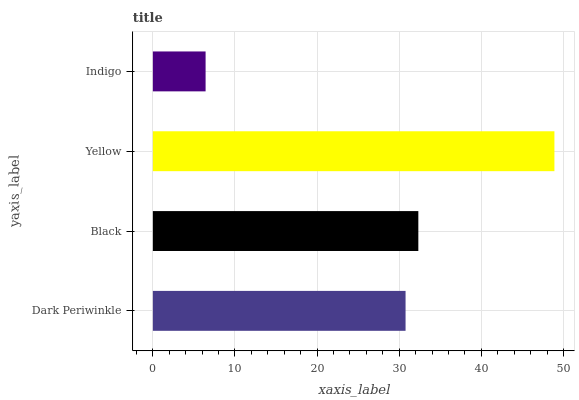Is Indigo the minimum?
Answer yes or no. Yes. Is Yellow the maximum?
Answer yes or no. Yes. Is Black the minimum?
Answer yes or no. No. Is Black the maximum?
Answer yes or no. No. Is Black greater than Dark Periwinkle?
Answer yes or no. Yes. Is Dark Periwinkle less than Black?
Answer yes or no. Yes. Is Dark Periwinkle greater than Black?
Answer yes or no. No. Is Black less than Dark Periwinkle?
Answer yes or no. No. Is Black the high median?
Answer yes or no. Yes. Is Dark Periwinkle the low median?
Answer yes or no. Yes. Is Indigo the high median?
Answer yes or no. No. Is Yellow the low median?
Answer yes or no. No. 